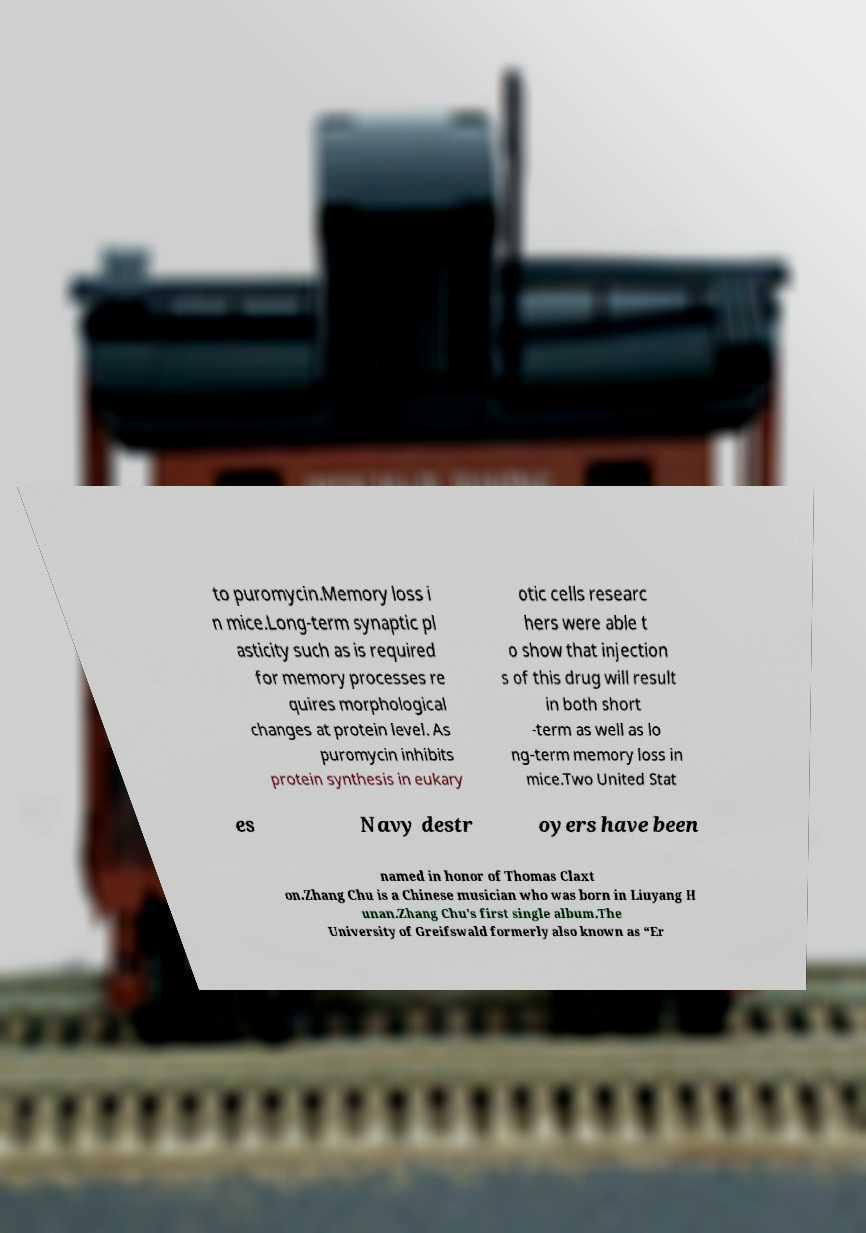I need the written content from this picture converted into text. Can you do that? to puromycin.Memory loss i n mice.Long-term synaptic pl asticity such as is required for memory processes re quires morphological changes at protein level. As puromycin inhibits protein synthesis in eukary otic cells researc hers were able t o show that injection s of this drug will result in both short -term as well as lo ng-term memory loss in mice.Two United Stat es Navy destr oyers have been named in honor of Thomas Claxt on.Zhang Chu is a Chinese musician who was born in Liuyang H unan.Zhang Chu's first single album.The University of Greifswald formerly also known as “Er 